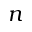Convert formula to latex. <formula><loc_0><loc_0><loc_500><loc_500>n</formula> 